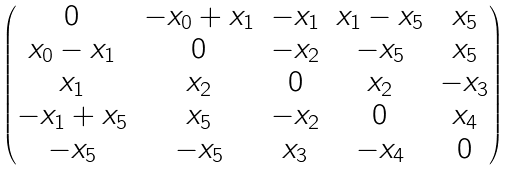Convert formula to latex. <formula><loc_0><loc_0><loc_500><loc_500>\begin{pmatrix} 0 & - x _ { 0 } + x _ { 1 } & - x _ { 1 } & x _ { 1 } - x _ { 5 } & x _ { 5 } \\ x _ { 0 } - x _ { 1 } & 0 & - x _ { 2 } & - x _ { 5 } & x _ { 5 } \\ x _ { 1 } & x _ { 2 } & 0 & x _ { 2 } & - x _ { 3 } \\ - x _ { 1 } + x _ { 5 } & x _ { 5 } & - x _ { 2 } & 0 & x _ { 4 } \\ - x _ { 5 } & - x _ { 5 } & x _ { 3 } & - x _ { 4 } & 0 \end{pmatrix}</formula> 